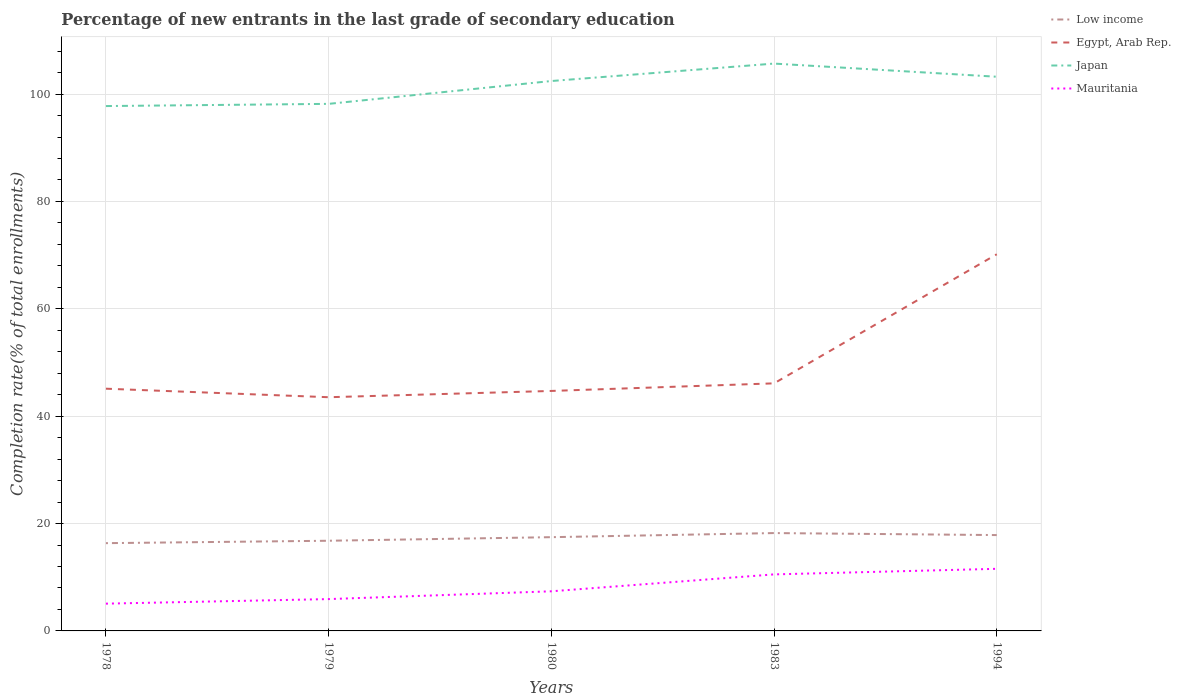How many different coloured lines are there?
Provide a short and direct response. 4. Does the line corresponding to Mauritania intersect with the line corresponding to Egypt, Arab Rep.?
Give a very brief answer. No. Is the number of lines equal to the number of legend labels?
Keep it short and to the point. Yes. Across all years, what is the maximum percentage of new entrants in Egypt, Arab Rep.?
Your answer should be very brief. 43.53. In which year was the percentage of new entrants in Low income maximum?
Make the answer very short. 1978. What is the total percentage of new entrants in Mauritania in the graph?
Your answer should be very brief. -3.15. What is the difference between the highest and the second highest percentage of new entrants in Egypt, Arab Rep.?
Your answer should be compact. 26.63. How many years are there in the graph?
Make the answer very short. 5. Does the graph contain any zero values?
Your answer should be very brief. No. Does the graph contain grids?
Offer a very short reply. Yes. How are the legend labels stacked?
Ensure brevity in your answer.  Vertical. What is the title of the graph?
Ensure brevity in your answer.  Percentage of new entrants in the last grade of secondary education. What is the label or title of the Y-axis?
Your answer should be very brief. Completion rate(% of total enrollments). What is the Completion rate(% of total enrollments) in Low income in 1978?
Offer a terse response. 16.35. What is the Completion rate(% of total enrollments) of Egypt, Arab Rep. in 1978?
Make the answer very short. 45.12. What is the Completion rate(% of total enrollments) in Japan in 1978?
Offer a very short reply. 97.77. What is the Completion rate(% of total enrollments) of Mauritania in 1978?
Make the answer very short. 5.08. What is the Completion rate(% of total enrollments) of Low income in 1979?
Offer a terse response. 16.8. What is the Completion rate(% of total enrollments) in Egypt, Arab Rep. in 1979?
Give a very brief answer. 43.53. What is the Completion rate(% of total enrollments) in Japan in 1979?
Offer a very short reply. 98.18. What is the Completion rate(% of total enrollments) of Mauritania in 1979?
Provide a short and direct response. 5.93. What is the Completion rate(% of total enrollments) in Low income in 1980?
Offer a terse response. 17.46. What is the Completion rate(% of total enrollments) in Egypt, Arab Rep. in 1980?
Ensure brevity in your answer.  44.7. What is the Completion rate(% of total enrollments) in Japan in 1980?
Make the answer very short. 102.44. What is the Completion rate(% of total enrollments) in Mauritania in 1980?
Your response must be concise. 7.38. What is the Completion rate(% of total enrollments) of Low income in 1983?
Your response must be concise. 18.23. What is the Completion rate(% of total enrollments) in Egypt, Arab Rep. in 1983?
Give a very brief answer. 46.12. What is the Completion rate(% of total enrollments) of Japan in 1983?
Make the answer very short. 105.69. What is the Completion rate(% of total enrollments) in Mauritania in 1983?
Ensure brevity in your answer.  10.53. What is the Completion rate(% of total enrollments) in Low income in 1994?
Provide a succinct answer. 17.86. What is the Completion rate(% of total enrollments) in Egypt, Arab Rep. in 1994?
Your answer should be very brief. 70.17. What is the Completion rate(% of total enrollments) of Japan in 1994?
Your response must be concise. 103.23. What is the Completion rate(% of total enrollments) of Mauritania in 1994?
Ensure brevity in your answer.  11.57. Across all years, what is the maximum Completion rate(% of total enrollments) of Low income?
Your answer should be very brief. 18.23. Across all years, what is the maximum Completion rate(% of total enrollments) of Egypt, Arab Rep.?
Your answer should be very brief. 70.17. Across all years, what is the maximum Completion rate(% of total enrollments) in Japan?
Your answer should be compact. 105.69. Across all years, what is the maximum Completion rate(% of total enrollments) in Mauritania?
Your response must be concise. 11.57. Across all years, what is the minimum Completion rate(% of total enrollments) of Low income?
Offer a terse response. 16.35. Across all years, what is the minimum Completion rate(% of total enrollments) in Egypt, Arab Rep.?
Provide a short and direct response. 43.53. Across all years, what is the minimum Completion rate(% of total enrollments) in Japan?
Make the answer very short. 97.77. Across all years, what is the minimum Completion rate(% of total enrollments) of Mauritania?
Offer a very short reply. 5.08. What is the total Completion rate(% of total enrollments) in Low income in the graph?
Offer a terse response. 86.7. What is the total Completion rate(% of total enrollments) of Egypt, Arab Rep. in the graph?
Make the answer very short. 249.65. What is the total Completion rate(% of total enrollments) in Japan in the graph?
Your response must be concise. 507.31. What is the total Completion rate(% of total enrollments) in Mauritania in the graph?
Provide a short and direct response. 40.49. What is the difference between the Completion rate(% of total enrollments) of Low income in 1978 and that in 1979?
Offer a terse response. -0.45. What is the difference between the Completion rate(% of total enrollments) of Egypt, Arab Rep. in 1978 and that in 1979?
Your answer should be very brief. 1.59. What is the difference between the Completion rate(% of total enrollments) in Japan in 1978 and that in 1979?
Your answer should be compact. -0.41. What is the difference between the Completion rate(% of total enrollments) in Mauritania in 1978 and that in 1979?
Offer a very short reply. -0.85. What is the difference between the Completion rate(% of total enrollments) of Low income in 1978 and that in 1980?
Offer a terse response. -1.11. What is the difference between the Completion rate(% of total enrollments) of Egypt, Arab Rep. in 1978 and that in 1980?
Offer a terse response. 0.42. What is the difference between the Completion rate(% of total enrollments) in Japan in 1978 and that in 1980?
Offer a terse response. -4.66. What is the difference between the Completion rate(% of total enrollments) of Mauritania in 1978 and that in 1980?
Offer a very short reply. -2.3. What is the difference between the Completion rate(% of total enrollments) of Low income in 1978 and that in 1983?
Give a very brief answer. -1.88. What is the difference between the Completion rate(% of total enrollments) of Egypt, Arab Rep. in 1978 and that in 1983?
Offer a very short reply. -0.99. What is the difference between the Completion rate(% of total enrollments) of Japan in 1978 and that in 1983?
Provide a short and direct response. -7.91. What is the difference between the Completion rate(% of total enrollments) of Mauritania in 1978 and that in 1983?
Provide a short and direct response. -5.45. What is the difference between the Completion rate(% of total enrollments) in Low income in 1978 and that in 1994?
Make the answer very short. -1.51. What is the difference between the Completion rate(% of total enrollments) in Egypt, Arab Rep. in 1978 and that in 1994?
Give a very brief answer. -25.04. What is the difference between the Completion rate(% of total enrollments) in Japan in 1978 and that in 1994?
Your answer should be very brief. -5.46. What is the difference between the Completion rate(% of total enrollments) in Mauritania in 1978 and that in 1994?
Offer a very short reply. -6.49. What is the difference between the Completion rate(% of total enrollments) in Egypt, Arab Rep. in 1979 and that in 1980?
Your answer should be very brief. -1.17. What is the difference between the Completion rate(% of total enrollments) of Japan in 1979 and that in 1980?
Your response must be concise. -4.25. What is the difference between the Completion rate(% of total enrollments) in Mauritania in 1979 and that in 1980?
Provide a short and direct response. -1.45. What is the difference between the Completion rate(% of total enrollments) of Low income in 1979 and that in 1983?
Ensure brevity in your answer.  -1.43. What is the difference between the Completion rate(% of total enrollments) of Egypt, Arab Rep. in 1979 and that in 1983?
Provide a short and direct response. -2.58. What is the difference between the Completion rate(% of total enrollments) of Japan in 1979 and that in 1983?
Provide a succinct answer. -7.5. What is the difference between the Completion rate(% of total enrollments) in Mauritania in 1979 and that in 1983?
Make the answer very short. -4.6. What is the difference between the Completion rate(% of total enrollments) in Low income in 1979 and that in 1994?
Provide a short and direct response. -1.06. What is the difference between the Completion rate(% of total enrollments) in Egypt, Arab Rep. in 1979 and that in 1994?
Provide a succinct answer. -26.63. What is the difference between the Completion rate(% of total enrollments) in Japan in 1979 and that in 1994?
Your response must be concise. -5.05. What is the difference between the Completion rate(% of total enrollments) in Mauritania in 1979 and that in 1994?
Your answer should be very brief. -5.64. What is the difference between the Completion rate(% of total enrollments) in Low income in 1980 and that in 1983?
Your answer should be very brief. -0.76. What is the difference between the Completion rate(% of total enrollments) in Egypt, Arab Rep. in 1980 and that in 1983?
Your response must be concise. -1.41. What is the difference between the Completion rate(% of total enrollments) of Japan in 1980 and that in 1983?
Provide a short and direct response. -3.25. What is the difference between the Completion rate(% of total enrollments) of Mauritania in 1980 and that in 1983?
Provide a succinct answer. -3.15. What is the difference between the Completion rate(% of total enrollments) of Low income in 1980 and that in 1994?
Keep it short and to the point. -0.39. What is the difference between the Completion rate(% of total enrollments) of Egypt, Arab Rep. in 1980 and that in 1994?
Make the answer very short. -25.46. What is the difference between the Completion rate(% of total enrollments) of Japan in 1980 and that in 1994?
Keep it short and to the point. -0.8. What is the difference between the Completion rate(% of total enrollments) in Mauritania in 1980 and that in 1994?
Make the answer very short. -4.19. What is the difference between the Completion rate(% of total enrollments) in Low income in 1983 and that in 1994?
Offer a very short reply. 0.37. What is the difference between the Completion rate(% of total enrollments) in Egypt, Arab Rep. in 1983 and that in 1994?
Your answer should be compact. -24.05. What is the difference between the Completion rate(% of total enrollments) in Japan in 1983 and that in 1994?
Your response must be concise. 2.45. What is the difference between the Completion rate(% of total enrollments) in Mauritania in 1983 and that in 1994?
Provide a short and direct response. -1.04. What is the difference between the Completion rate(% of total enrollments) in Low income in 1978 and the Completion rate(% of total enrollments) in Egypt, Arab Rep. in 1979?
Give a very brief answer. -27.19. What is the difference between the Completion rate(% of total enrollments) of Low income in 1978 and the Completion rate(% of total enrollments) of Japan in 1979?
Your response must be concise. -81.83. What is the difference between the Completion rate(% of total enrollments) in Low income in 1978 and the Completion rate(% of total enrollments) in Mauritania in 1979?
Ensure brevity in your answer.  10.42. What is the difference between the Completion rate(% of total enrollments) of Egypt, Arab Rep. in 1978 and the Completion rate(% of total enrollments) of Japan in 1979?
Make the answer very short. -53.06. What is the difference between the Completion rate(% of total enrollments) of Egypt, Arab Rep. in 1978 and the Completion rate(% of total enrollments) of Mauritania in 1979?
Ensure brevity in your answer.  39.19. What is the difference between the Completion rate(% of total enrollments) of Japan in 1978 and the Completion rate(% of total enrollments) of Mauritania in 1979?
Offer a terse response. 91.84. What is the difference between the Completion rate(% of total enrollments) of Low income in 1978 and the Completion rate(% of total enrollments) of Egypt, Arab Rep. in 1980?
Your answer should be compact. -28.35. What is the difference between the Completion rate(% of total enrollments) of Low income in 1978 and the Completion rate(% of total enrollments) of Japan in 1980?
Your answer should be compact. -86.09. What is the difference between the Completion rate(% of total enrollments) of Low income in 1978 and the Completion rate(% of total enrollments) of Mauritania in 1980?
Keep it short and to the point. 8.97. What is the difference between the Completion rate(% of total enrollments) of Egypt, Arab Rep. in 1978 and the Completion rate(% of total enrollments) of Japan in 1980?
Your answer should be compact. -57.31. What is the difference between the Completion rate(% of total enrollments) of Egypt, Arab Rep. in 1978 and the Completion rate(% of total enrollments) of Mauritania in 1980?
Make the answer very short. 37.74. What is the difference between the Completion rate(% of total enrollments) of Japan in 1978 and the Completion rate(% of total enrollments) of Mauritania in 1980?
Give a very brief answer. 90.39. What is the difference between the Completion rate(% of total enrollments) in Low income in 1978 and the Completion rate(% of total enrollments) in Egypt, Arab Rep. in 1983?
Make the answer very short. -29.77. What is the difference between the Completion rate(% of total enrollments) of Low income in 1978 and the Completion rate(% of total enrollments) of Japan in 1983?
Ensure brevity in your answer.  -89.34. What is the difference between the Completion rate(% of total enrollments) in Low income in 1978 and the Completion rate(% of total enrollments) in Mauritania in 1983?
Offer a terse response. 5.82. What is the difference between the Completion rate(% of total enrollments) of Egypt, Arab Rep. in 1978 and the Completion rate(% of total enrollments) of Japan in 1983?
Your answer should be very brief. -60.56. What is the difference between the Completion rate(% of total enrollments) of Egypt, Arab Rep. in 1978 and the Completion rate(% of total enrollments) of Mauritania in 1983?
Keep it short and to the point. 34.59. What is the difference between the Completion rate(% of total enrollments) of Japan in 1978 and the Completion rate(% of total enrollments) of Mauritania in 1983?
Give a very brief answer. 87.24. What is the difference between the Completion rate(% of total enrollments) of Low income in 1978 and the Completion rate(% of total enrollments) of Egypt, Arab Rep. in 1994?
Offer a very short reply. -53.82. What is the difference between the Completion rate(% of total enrollments) of Low income in 1978 and the Completion rate(% of total enrollments) of Japan in 1994?
Make the answer very short. -86.89. What is the difference between the Completion rate(% of total enrollments) of Low income in 1978 and the Completion rate(% of total enrollments) of Mauritania in 1994?
Provide a short and direct response. 4.78. What is the difference between the Completion rate(% of total enrollments) in Egypt, Arab Rep. in 1978 and the Completion rate(% of total enrollments) in Japan in 1994?
Your answer should be very brief. -58.11. What is the difference between the Completion rate(% of total enrollments) of Egypt, Arab Rep. in 1978 and the Completion rate(% of total enrollments) of Mauritania in 1994?
Your answer should be very brief. 33.55. What is the difference between the Completion rate(% of total enrollments) in Japan in 1978 and the Completion rate(% of total enrollments) in Mauritania in 1994?
Make the answer very short. 86.2. What is the difference between the Completion rate(% of total enrollments) in Low income in 1979 and the Completion rate(% of total enrollments) in Egypt, Arab Rep. in 1980?
Your answer should be very brief. -27.91. What is the difference between the Completion rate(% of total enrollments) of Low income in 1979 and the Completion rate(% of total enrollments) of Japan in 1980?
Ensure brevity in your answer.  -85.64. What is the difference between the Completion rate(% of total enrollments) of Low income in 1979 and the Completion rate(% of total enrollments) of Mauritania in 1980?
Provide a short and direct response. 9.42. What is the difference between the Completion rate(% of total enrollments) in Egypt, Arab Rep. in 1979 and the Completion rate(% of total enrollments) in Japan in 1980?
Your answer should be very brief. -58.9. What is the difference between the Completion rate(% of total enrollments) in Egypt, Arab Rep. in 1979 and the Completion rate(% of total enrollments) in Mauritania in 1980?
Your answer should be compact. 36.15. What is the difference between the Completion rate(% of total enrollments) of Japan in 1979 and the Completion rate(% of total enrollments) of Mauritania in 1980?
Make the answer very short. 90.8. What is the difference between the Completion rate(% of total enrollments) of Low income in 1979 and the Completion rate(% of total enrollments) of Egypt, Arab Rep. in 1983?
Make the answer very short. -29.32. What is the difference between the Completion rate(% of total enrollments) of Low income in 1979 and the Completion rate(% of total enrollments) of Japan in 1983?
Your response must be concise. -88.89. What is the difference between the Completion rate(% of total enrollments) in Low income in 1979 and the Completion rate(% of total enrollments) in Mauritania in 1983?
Your answer should be compact. 6.27. What is the difference between the Completion rate(% of total enrollments) of Egypt, Arab Rep. in 1979 and the Completion rate(% of total enrollments) of Japan in 1983?
Make the answer very short. -62.15. What is the difference between the Completion rate(% of total enrollments) in Egypt, Arab Rep. in 1979 and the Completion rate(% of total enrollments) in Mauritania in 1983?
Make the answer very short. 33. What is the difference between the Completion rate(% of total enrollments) in Japan in 1979 and the Completion rate(% of total enrollments) in Mauritania in 1983?
Your answer should be compact. 87.65. What is the difference between the Completion rate(% of total enrollments) in Low income in 1979 and the Completion rate(% of total enrollments) in Egypt, Arab Rep. in 1994?
Your answer should be compact. -53.37. What is the difference between the Completion rate(% of total enrollments) in Low income in 1979 and the Completion rate(% of total enrollments) in Japan in 1994?
Keep it short and to the point. -86.44. What is the difference between the Completion rate(% of total enrollments) in Low income in 1979 and the Completion rate(% of total enrollments) in Mauritania in 1994?
Provide a short and direct response. 5.23. What is the difference between the Completion rate(% of total enrollments) in Egypt, Arab Rep. in 1979 and the Completion rate(% of total enrollments) in Japan in 1994?
Your answer should be compact. -59.7. What is the difference between the Completion rate(% of total enrollments) in Egypt, Arab Rep. in 1979 and the Completion rate(% of total enrollments) in Mauritania in 1994?
Offer a terse response. 31.97. What is the difference between the Completion rate(% of total enrollments) of Japan in 1979 and the Completion rate(% of total enrollments) of Mauritania in 1994?
Ensure brevity in your answer.  86.61. What is the difference between the Completion rate(% of total enrollments) in Low income in 1980 and the Completion rate(% of total enrollments) in Egypt, Arab Rep. in 1983?
Your answer should be very brief. -28.65. What is the difference between the Completion rate(% of total enrollments) in Low income in 1980 and the Completion rate(% of total enrollments) in Japan in 1983?
Make the answer very short. -88.22. What is the difference between the Completion rate(% of total enrollments) of Low income in 1980 and the Completion rate(% of total enrollments) of Mauritania in 1983?
Keep it short and to the point. 6.93. What is the difference between the Completion rate(% of total enrollments) in Egypt, Arab Rep. in 1980 and the Completion rate(% of total enrollments) in Japan in 1983?
Make the answer very short. -60.98. What is the difference between the Completion rate(% of total enrollments) of Egypt, Arab Rep. in 1980 and the Completion rate(% of total enrollments) of Mauritania in 1983?
Your answer should be compact. 34.17. What is the difference between the Completion rate(% of total enrollments) in Japan in 1980 and the Completion rate(% of total enrollments) in Mauritania in 1983?
Provide a short and direct response. 91.91. What is the difference between the Completion rate(% of total enrollments) of Low income in 1980 and the Completion rate(% of total enrollments) of Egypt, Arab Rep. in 1994?
Ensure brevity in your answer.  -52.7. What is the difference between the Completion rate(% of total enrollments) of Low income in 1980 and the Completion rate(% of total enrollments) of Japan in 1994?
Make the answer very short. -85.77. What is the difference between the Completion rate(% of total enrollments) in Low income in 1980 and the Completion rate(% of total enrollments) in Mauritania in 1994?
Offer a terse response. 5.9. What is the difference between the Completion rate(% of total enrollments) in Egypt, Arab Rep. in 1980 and the Completion rate(% of total enrollments) in Japan in 1994?
Offer a very short reply. -58.53. What is the difference between the Completion rate(% of total enrollments) in Egypt, Arab Rep. in 1980 and the Completion rate(% of total enrollments) in Mauritania in 1994?
Provide a short and direct response. 33.13. What is the difference between the Completion rate(% of total enrollments) in Japan in 1980 and the Completion rate(% of total enrollments) in Mauritania in 1994?
Make the answer very short. 90.87. What is the difference between the Completion rate(% of total enrollments) in Low income in 1983 and the Completion rate(% of total enrollments) in Egypt, Arab Rep. in 1994?
Your answer should be compact. -51.94. What is the difference between the Completion rate(% of total enrollments) in Low income in 1983 and the Completion rate(% of total enrollments) in Japan in 1994?
Make the answer very short. -85.01. What is the difference between the Completion rate(% of total enrollments) in Low income in 1983 and the Completion rate(% of total enrollments) in Mauritania in 1994?
Make the answer very short. 6.66. What is the difference between the Completion rate(% of total enrollments) of Egypt, Arab Rep. in 1983 and the Completion rate(% of total enrollments) of Japan in 1994?
Ensure brevity in your answer.  -57.12. What is the difference between the Completion rate(% of total enrollments) in Egypt, Arab Rep. in 1983 and the Completion rate(% of total enrollments) in Mauritania in 1994?
Offer a terse response. 34.55. What is the difference between the Completion rate(% of total enrollments) in Japan in 1983 and the Completion rate(% of total enrollments) in Mauritania in 1994?
Your answer should be compact. 94.12. What is the average Completion rate(% of total enrollments) in Low income per year?
Ensure brevity in your answer.  17.34. What is the average Completion rate(% of total enrollments) in Egypt, Arab Rep. per year?
Provide a succinct answer. 49.93. What is the average Completion rate(% of total enrollments) in Japan per year?
Offer a terse response. 101.46. What is the average Completion rate(% of total enrollments) of Mauritania per year?
Keep it short and to the point. 8.1. In the year 1978, what is the difference between the Completion rate(% of total enrollments) in Low income and Completion rate(% of total enrollments) in Egypt, Arab Rep.?
Give a very brief answer. -28.77. In the year 1978, what is the difference between the Completion rate(% of total enrollments) of Low income and Completion rate(% of total enrollments) of Japan?
Offer a very short reply. -81.42. In the year 1978, what is the difference between the Completion rate(% of total enrollments) of Low income and Completion rate(% of total enrollments) of Mauritania?
Make the answer very short. 11.27. In the year 1978, what is the difference between the Completion rate(% of total enrollments) in Egypt, Arab Rep. and Completion rate(% of total enrollments) in Japan?
Offer a terse response. -52.65. In the year 1978, what is the difference between the Completion rate(% of total enrollments) in Egypt, Arab Rep. and Completion rate(% of total enrollments) in Mauritania?
Ensure brevity in your answer.  40.04. In the year 1978, what is the difference between the Completion rate(% of total enrollments) of Japan and Completion rate(% of total enrollments) of Mauritania?
Offer a very short reply. 92.69. In the year 1979, what is the difference between the Completion rate(% of total enrollments) in Low income and Completion rate(% of total enrollments) in Egypt, Arab Rep.?
Your answer should be compact. -26.74. In the year 1979, what is the difference between the Completion rate(% of total enrollments) of Low income and Completion rate(% of total enrollments) of Japan?
Your answer should be compact. -81.38. In the year 1979, what is the difference between the Completion rate(% of total enrollments) of Low income and Completion rate(% of total enrollments) of Mauritania?
Offer a very short reply. 10.87. In the year 1979, what is the difference between the Completion rate(% of total enrollments) of Egypt, Arab Rep. and Completion rate(% of total enrollments) of Japan?
Offer a terse response. -54.65. In the year 1979, what is the difference between the Completion rate(% of total enrollments) of Egypt, Arab Rep. and Completion rate(% of total enrollments) of Mauritania?
Give a very brief answer. 37.61. In the year 1979, what is the difference between the Completion rate(% of total enrollments) of Japan and Completion rate(% of total enrollments) of Mauritania?
Provide a succinct answer. 92.25. In the year 1980, what is the difference between the Completion rate(% of total enrollments) in Low income and Completion rate(% of total enrollments) in Egypt, Arab Rep.?
Provide a short and direct response. -27.24. In the year 1980, what is the difference between the Completion rate(% of total enrollments) of Low income and Completion rate(% of total enrollments) of Japan?
Your answer should be very brief. -84.97. In the year 1980, what is the difference between the Completion rate(% of total enrollments) in Low income and Completion rate(% of total enrollments) in Mauritania?
Keep it short and to the point. 10.08. In the year 1980, what is the difference between the Completion rate(% of total enrollments) of Egypt, Arab Rep. and Completion rate(% of total enrollments) of Japan?
Make the answer very short. -57.73. In the year 1980, what is the difference between the Completion rate(% of total enrollments) of Egypt, Arab Rep. and Completion rate(% of total enrollments) of Mauritania?
Your response must be concise. 37.32. In the year 1980, what is the difference between the Completion rate(% of total enrollments) of Japan and Completion rate(% of total enrollments) of Mauritania?
Keep it short and to the point. 95.06. In the year 1983, what is the difference between the Completion rate(% of total enrollments) in Low income and Completion rate(% of total enrollments) in Egypt, Arab Rep.?
Give a very brief answer. -27.89. In the year 1983, what is the difference between the Completion rate(% of total enrollments) in Low income and Completion rate(% of total enrollments) in Japan?
Your answer should be very brief. -87.46. In the year 1983, what is the difference between the Completion rate(% of total enrollments) in Low income and Completion rate(% of total enrollments) in Mauritania?
Your answer should be compact. 7.7. In the year 1983, what is the difference between the Completion rate(% of total enrollments) of Egypt, Arab Rep. and Completion rate(% of total enrollments) of Japan?
Offer a very short reply. -59.57. In the year 1983, what is the difference between the Completion rate(% of total enrollments) of Egypt, Arab Rep. and Completion rate(% of total enrollments) of Mauritania?
Provide a short and direct response. 35.59. In the year 1983, what is the difference between the Completion rate(% of total enrollments) of Japan and Completion rate(% of total enrollments) of Mauritania?
Your response must be concise. 95.15. In the year 1994, what is the difference between the Completion rate(% of total enrollments) of Low income and Completion rate(% of total enrollments) of Egypt, Arab Rep.?
Your response must be concise. -52.31. In the year 1994, what is the difference between the Completion rate(% of total enrollments) in Low income and Completion rate(% of total enrollments) in Japan?
Your answer should be compact. -85.38. In the year 1994, what is the difference between the Completion rate(% of total enrollments) of Low income and Completion rate(% of total enrollments) of Mauritania?
Your answer should be very brief. 6.29. In the year 1994, what is the difference between the Completion rate(% of total enrollments) in Egypt, Arab Rep. and Completion rate(% of total enrollments) in Japan?
Your answer should be very brief. -33.07. In the year 1994, what is the difference between the Completion rate(% of total enrollments) of Egypt, Arab Rep. and Completion rate(% of total enrollments) of Mauritania?
Ensure brevity in your answer.  58.6. In the year 1994, what is the difference between the Completion rate(% of total enrollments) of Japan and Completion rate(% of total enrollments) of Mauritania?
Offer a terse response. 91.67. What is the ratio of the Completion rate(% of total enrollments) in Low income in 1978 to that in 1979?
Offer a very short reply. 0.97. What is the ratio of the Completion rate(% of total enrollments) of Egypt, Arab Rep. in 1978 to that in 1979?
Provide a short and direct response. 1.04. What is the ratio of the Completion rate(% of total enrollments) of Mauritania in 1978 to that in 1979?
Give a very brief answer. 0.86. What is the ratio of the Completion rate(% of total enrollments) in Low income in 1978 to that in 1980?
Your answer should be very brief. 0.94. What is the ratio of the Completion rate(% of total enrollments) of Egypt, Arab Rep. in 1978 to that in 1980?
Offer a very short reply. 1.01. What is the ratio of the Completion rate(% of total enrollments) in Japan in 1978 to that in 1980?
Your response must be concise. 0.95. What is the ratio of the Completion rate(% of total enrollments) of Mauritania in 1978 to that in 1980?
Provide a short and direct response. 0.69. What is the ratio of the Completion rate(% of total enrollments) of Low income in 1978 to that in 1983?
Provide a short and direct response. 0.9. What is the ratio of the Completion rate(% of total enrollments) in Egypt, Arab Rep. in 1978 to that in 1983?
Your answer should be compact. 0.98. What is the ratio of the Completion rate(% of total enrollments) of Japan in 1978 to that in 1983?
Give a very brief answer. 0.93. What is the ratio of the Completion rate(% of total enrollments) in Mauritania in 1978 to that in 1983?
Offer a very short reply. 0.48. What is the ratio of the Completion rate(% of total enrollments) of Low income in 1978 to that in 1994?
Make the answer very short. 0.92. What is the ratio of the Completion rate(% of total enrollments) in Egypt, Arab Rep. in 1978 to that in 1994?
Your answer should be compact. 0.64. What is the ratio of the Completion rate(% of total enrollments) in Japan in 1978 to that in 1994?
Offer a very short reply. 0.95. What is the ratio of the Completion rate(% of total enrollments) of Mauritania in 1978 to that in 1994?
Your answer should be compact. 0.44. What is the ratio of the Completion rate(% of total enrollments) of Low income in 1979 to that in 1980?
Provide a succinct answer. 0.96. What is the ratio of the Completion rate(% of total enrollments) of Egypt, Arab Rep. in 1979 to that in 1980?
Provide a succinct answer. 0.97. What is the ratio of the Completion rate(% of total enrollments) in Japan in 1979 to that in 1980?
Offer a very short reply. 0.96. What is the ratio of the Completion rate(% of total enrollments) in Mauritania in 1979 to that in 1980?
Offer a very short reply. 0.8. What is the ratio of the Completion rate(% of total enrollments) in Low income in 1979 to that in 1983?
Your answer should be compact. 0.92. What is the ratio of the Completion rate(% of total enrollments) of Egypt, Arab Rep. in 1979 to that in 1983?
Keep it short and to the point. 0.94. What is the ratio of the Completion rate(% of total enrollments) of Japan in 1979 to that in 1983?
Offer a terse response. 0.93. What is the ratio of the Completion rate(% of total enrollments) of Mauritania in 1979 to that in 1983?
Provide a short and direct response. 0.56. What is the ratio of the Completion rate(% of total enrollments) in Low income in 1979 to that in 1994?
Your response must be concise. 0.94. What is the ratio of the Completion rate(% of total enrollments) in Egypt, Arab Rep. in 1979 to that in 1994?
Your answer should be compact. 0.62. What is the ratio of the Completion rate(% of total enrollments) in Japan in 1979 to that in 1994?
Provide a short and direct response. 0.95. What is the ratio of the Completion rate(% of total enrollments) in Mauritania in 1979 to that in 1994?
Provide a succinct answer. 0.51. What is the ratio of the Completion rate(% of total enrollments) in Low income in 1980 to that in 1983?
Offer a very short reply. 0.96. What is the ratio of the Completion rate(% of total enrollments) of Egypt, Arab Rep. in 1980 to that in 1983?
Your answer should be compact. 0.97. What is the ratio of the Completion rate(% of total enrollments) in Japan in 1980 to that in 1983?
Keep it short and to the point. 0.97. What is the ratio of the Completion rate(% of total enrollments) in Mauritania in 1980 to that in 1983?
Your answer should be compact. 0.7. What is the ratio of the Completion rate(% of total enrollments) in Low income in 1980 to that in 1994?
Ensure brevity in your answer.  0.98. What is the ratio of the Completion rate(% of total enrollments) in Egypt, Arab Rep. in 1980 to that in 1994?
Offer a very short reply. 0.64. What is the ratio of the Completion rate(% of total enrollments) in Japan in 1980 to that in 1994?
Keep it short and to the point. 0.99. What is the ratio of the Completion rate(% of total enrollments) in Mauritania in 1980 to that in 1994?
Provide a succinct answer. 0.64. What is the ratio of the Completion rate(% of total enrollments) in Low income in 1983 to that in 1994?
Provide a short and direct response. 1.02. What is the ratio of the Completion rate(% of total enrollments) of Egypt, Arab Rep. in 1983 to that in 1994?
Give a very brief answer. 0.66. What is the ratio of the Completion rate(% of total enrollments) of Japan in 1983 to that in 1994?
Give a very brief answer. 1.02. What is the ratio of the Completion rate(% of total enrollments) in Mauritania in 1983 to that in 1994?
Keep it short and to the point. 0.91. What is the difference between the highest and the second highest Completion rate(% of total enrollments) in Low income?
Your answer should be very brief. 0.37. What is the difference between the highest and the second highest Completion rate(% of total enrollments) of Egypt, Arab Rep.?
Your answer should be compact. 24.05. What is the difference between the highest and the second highest Completion rate(% of total enrollments) in Japan?
Ensure brevity in your answer.  2.45. What is the difference between the highest and the second highest Completion rate(% of total enrollments) of Mauritania?
Your response must be concise. 1.04. What is the difference between the highest and the lowest Completion rate(% of total enrollments) of Low income?
Ensure brevity in your answer.  1.88. What is the difference between the highest and the lowest Completion rate(% of total enrollments) in Egypt, Arab Rep.?
Make the answer very short. 26.63. What is the difference between the highest and the lowest Completion rate(% of total enrollments) in Japan?
Offer a terse response. 7.91. What is the difference between the highest and the lowest Completion rate(% of total enrollments) of Mauritania?
Your answer should be compact. 6.49. 